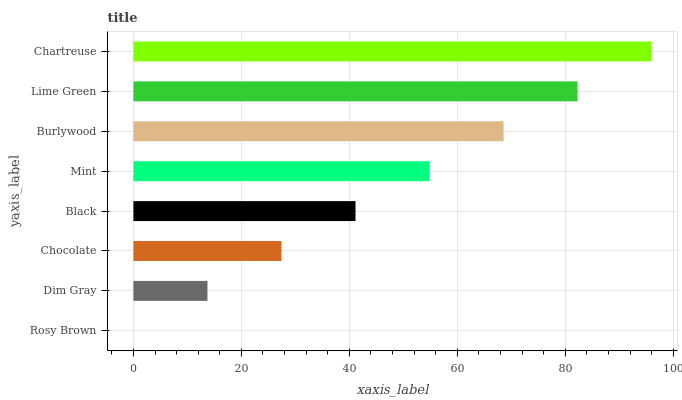Is Rosy Brown the minimum?
Answer yes or no. Yes. Is Chartreuse the maximum?
Answer yes or no. Yes. Is Dim Gray the minimum?
Answer yes or no. No. Is Dim Gray the maximum?
Answer yes or no. No. Is Dim Gray greater than Rosy Brown?
Answer yes or no. Yes. Is Rosy Brown less than Dim Gray?
Answer yes or no. Yes. Is Rosy Brown greater than Dim Gray?
Answer yes or no. No. Is Dim Gray less than Rosy Brown?
Answer yes or no. No. Is Mint the high median?
Answer yes or no. Yes. Is Black the low median?
Answer yes or no. Yes. Is Dim Gray the high median?
Answer yes or no. No. Is Mint the low median?
Answer yes or no. No. 